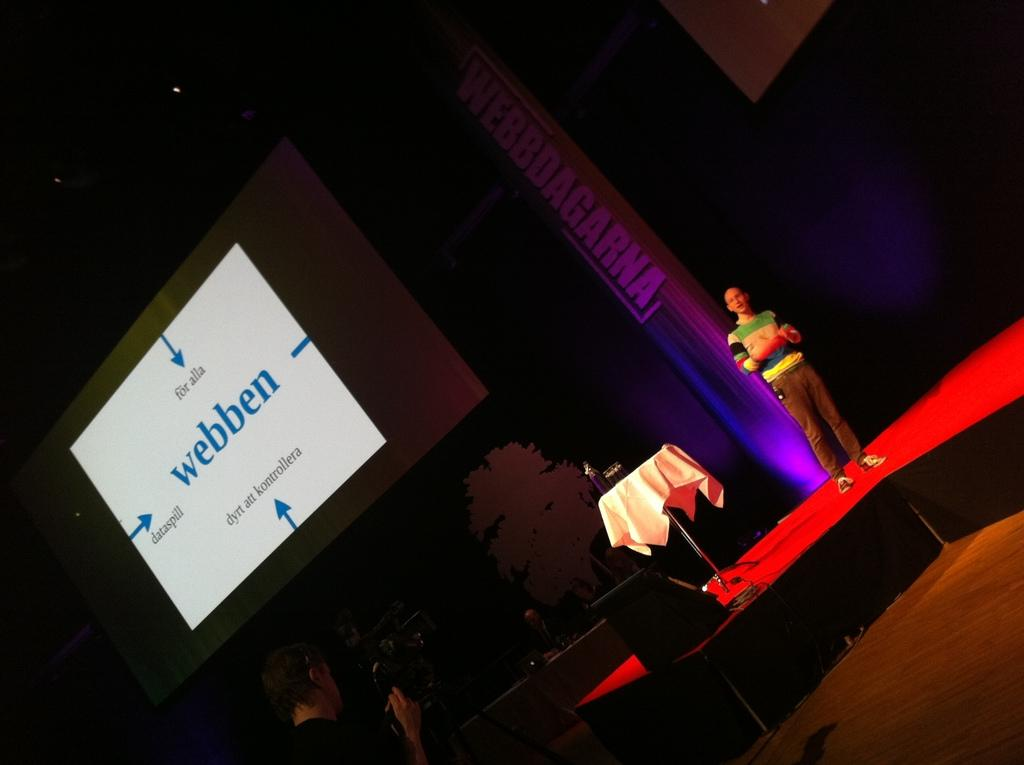Who is present in the image? There is a woman in the image. What is the woman standing on? The woman is standing on a red carpet. What can be seen on the wall in the image? There is a projector display on the wall. Where is the projector display located in the image? The projector display is on the left side of the image. What type of arch can be seen in the image? There is no arch present in the image. What kind of cloth is draped over the woman's shoulders in the image? There is no cloth draped over the woman's shoulders in the image. 